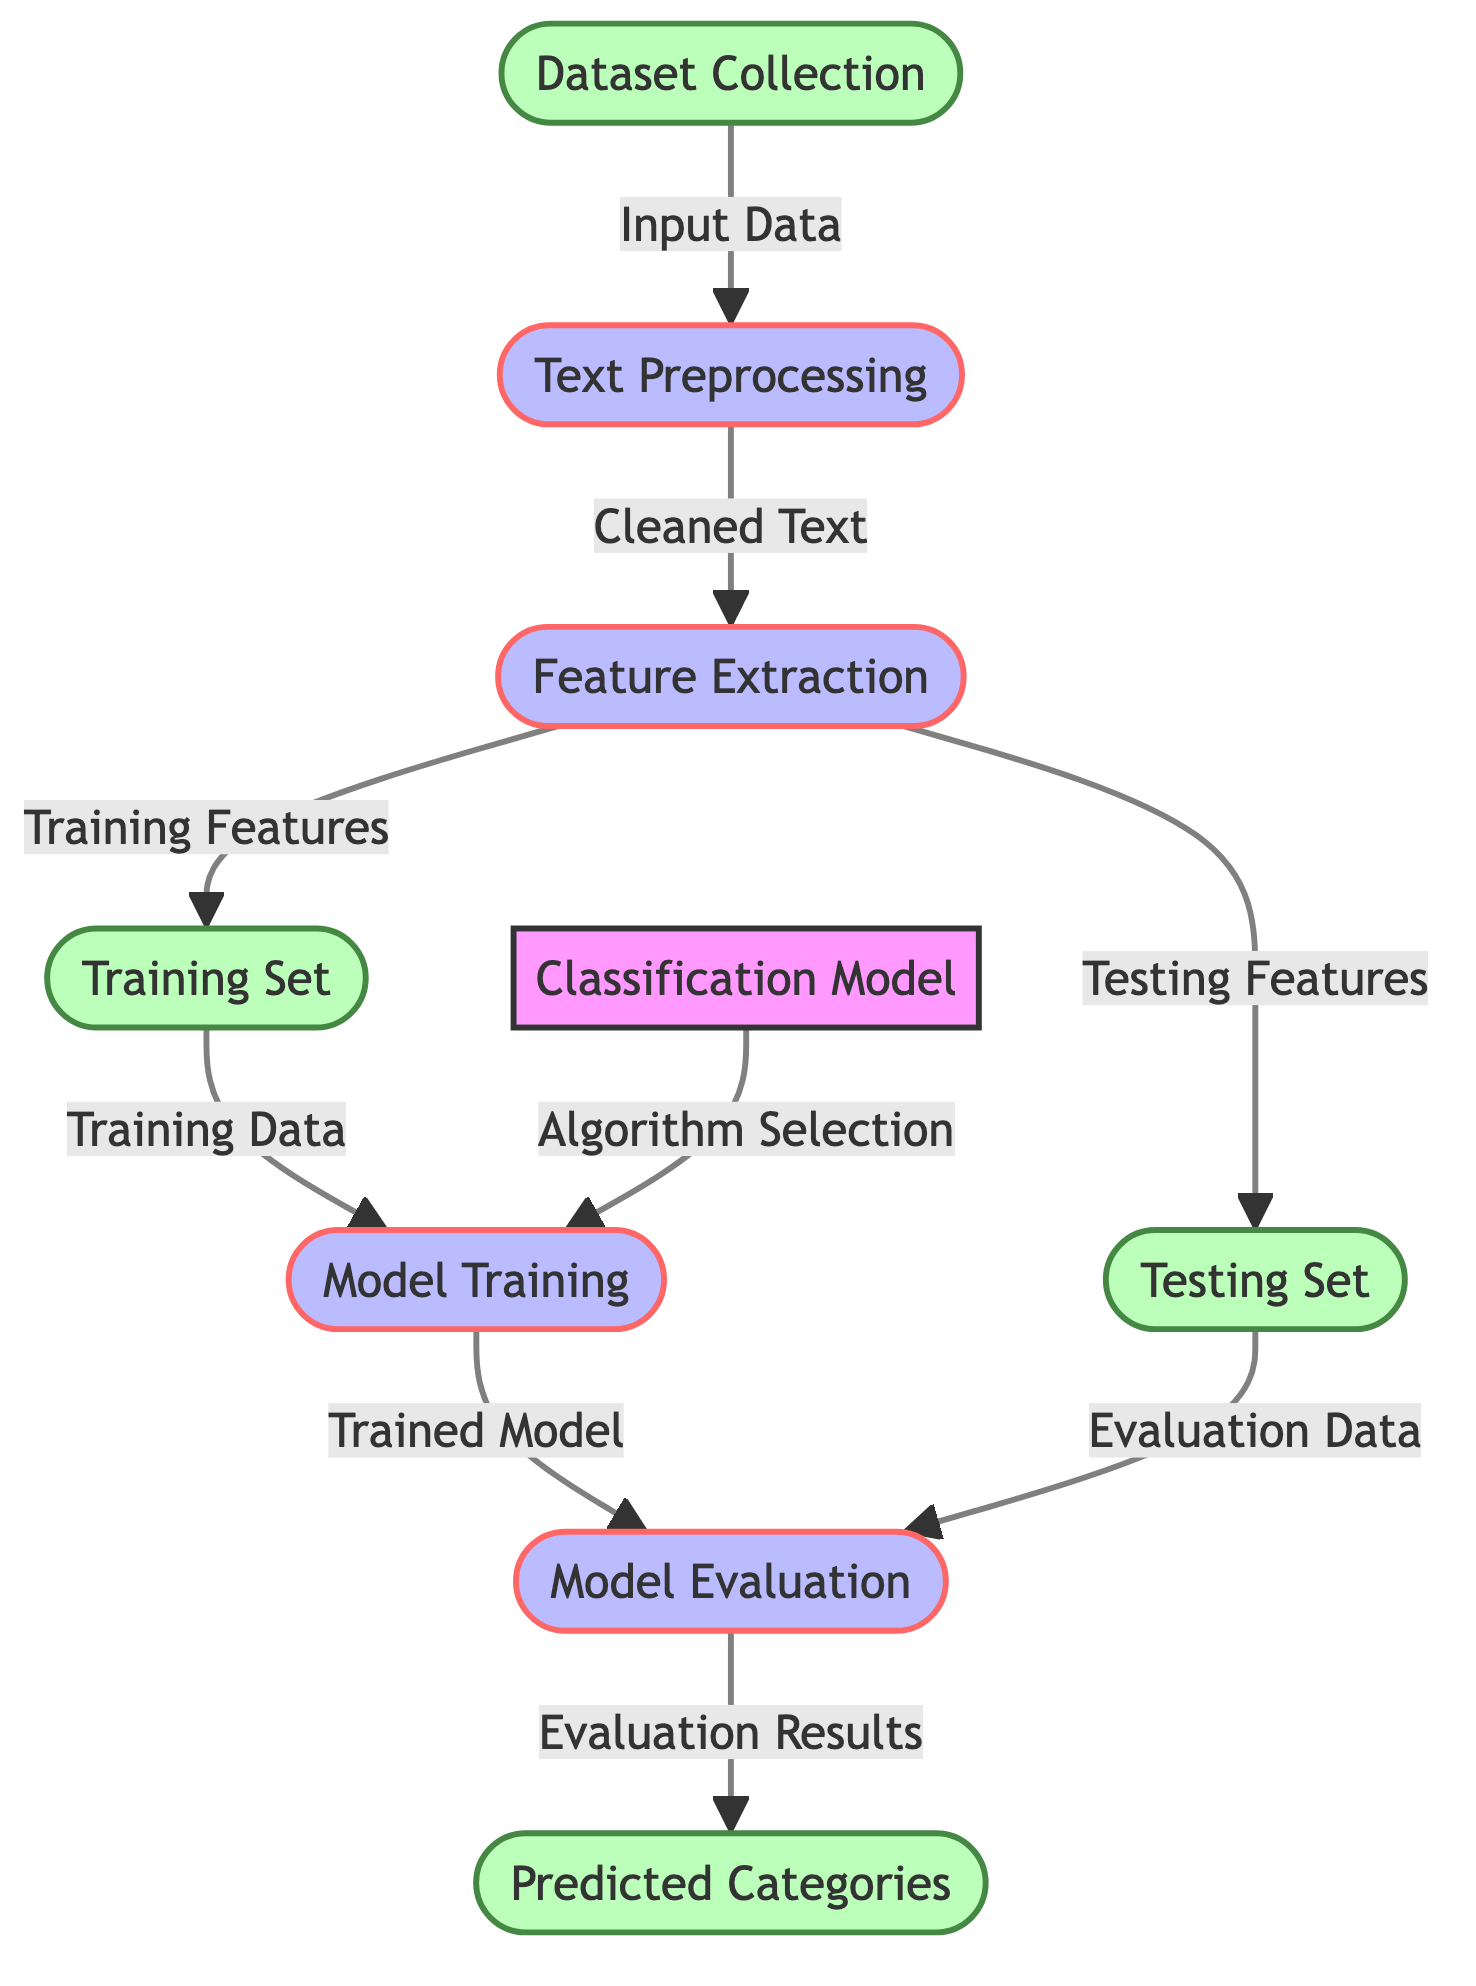What is the first step in the diagram? The diagram starts with the "Dataset Collection" node, indicating that gathering data is the initial phase of the process.
Answer: Dataset Collection How many processes are involved in the diagram? The diagram shows four process nodes: Text Preprocessing, Feature Extraction, Model Training, and Model Evaluation, making a total of four processes.
Answer: Four What is the output of the "Model Evaluation"? The output from the Model Evaluation is "Evaluation Results," which is the next node following the evaluation process in the diagram.
Answer: Evaluation Results What do the arrows represent in the diagram? The arrows illustrate the flow of data and processes between different nodes, indicating the sequence and dependencies within the classification model framework.
Answer: Flow of data and processes Which node follows "Feature Extraction"? "Training Set" and "Testing Set" represent the two nodes that follow the "Feature Extraction" node, indicating the results of feature extraction for training and testing purposes.
Answer: Training Set and Testing Set What is processed after the "Text Preprocessing"? The "Feature Extraction" process comes after "Text Preprocessing," suggesting that once the text data is cleaned, features are extracted for further analysis.
Answer: Feature Extraction How many input data paths lead into "Model Training"? There is one path leading into "Model Training," which comes from the "Training Set" node, indicating that the training data is used for training the model.
Answer: One What is the purpose of the "Classification Model" node? The "Classification Model" node signifies the core algorithm that will categorize the author's writing style and genre based on the processed data.
Answer: Core algorithm What is the final output of the diagram? The final output represented in the diagram is "Predicted Categories," signifying the results after evaluating the model's performance on testing data.
Answer: Predicted Categories 